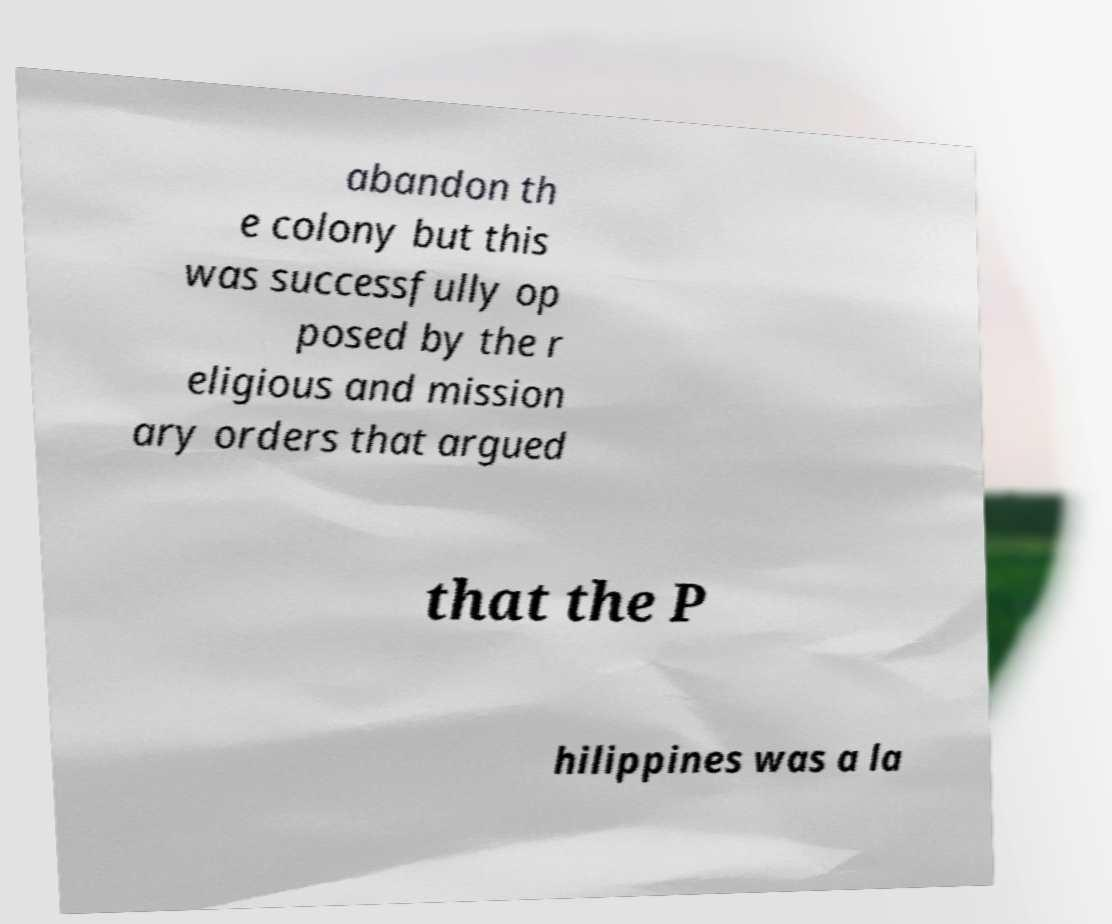For documentation purposes, I need the text within this image transcribed. Could you provide that? abandon th e colony but this was successfully op posed by the r eligious and mission ary orders that argued that the P hilippines was a la 